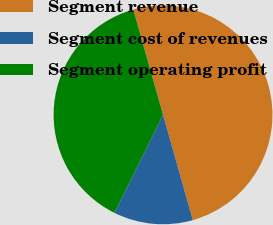Convert chart to OTSL. <chart><loc_0><loc_0><loc_500><loc_500><pie_chart><fcel>Segment revenue<fcel>Segment cost of revenues<fcel>Segment operating profit<nl><fcel>50.0%<fcel>11.72%<fcel>38.28%<nl></chart> 